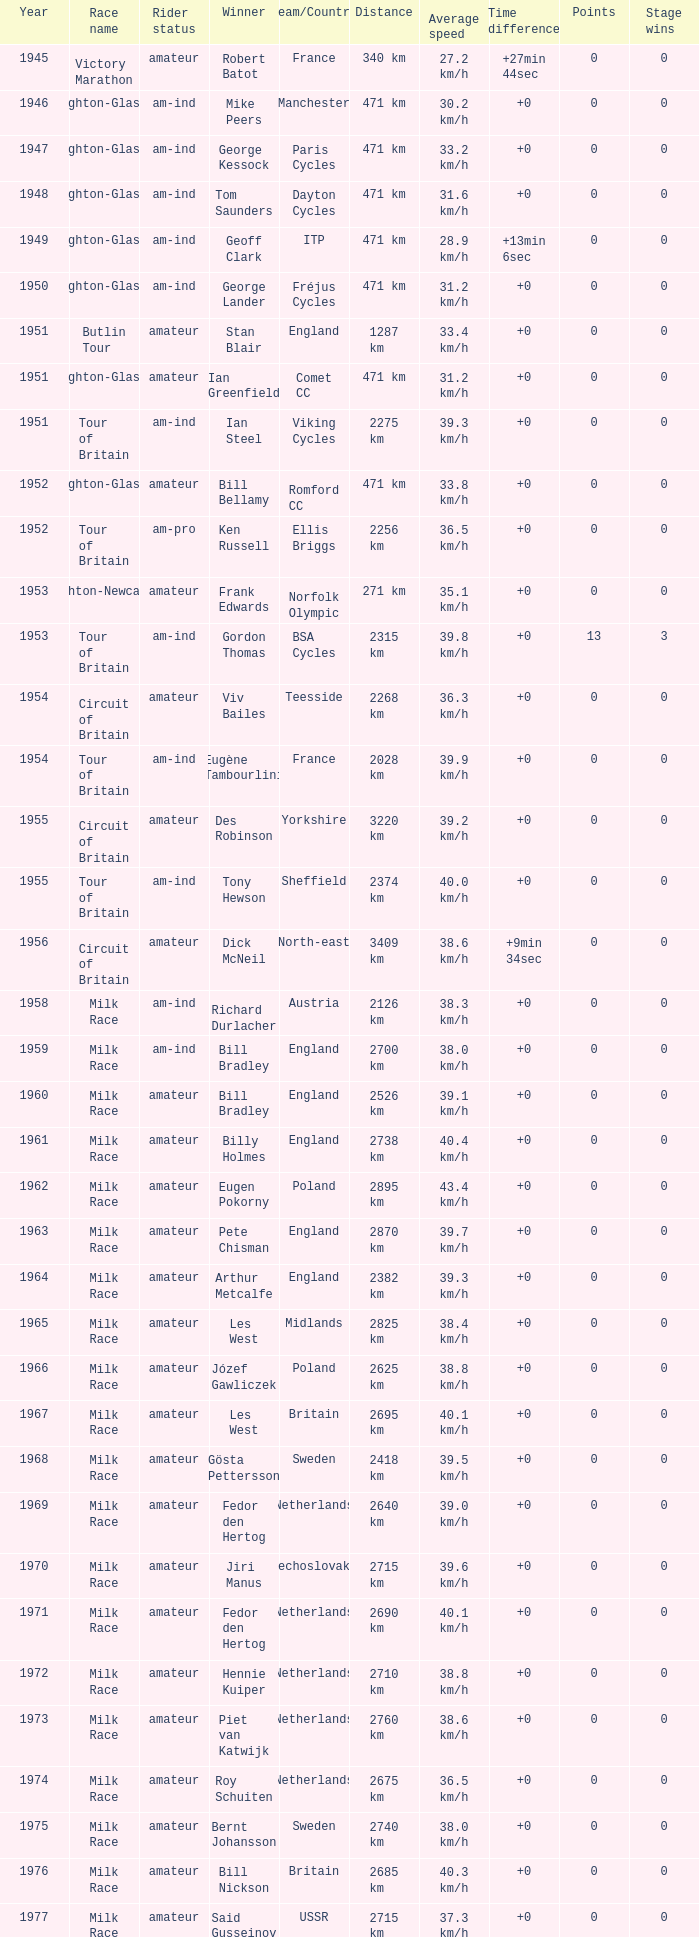What is the rider status for the 1971 netherlands team? Amateur. 